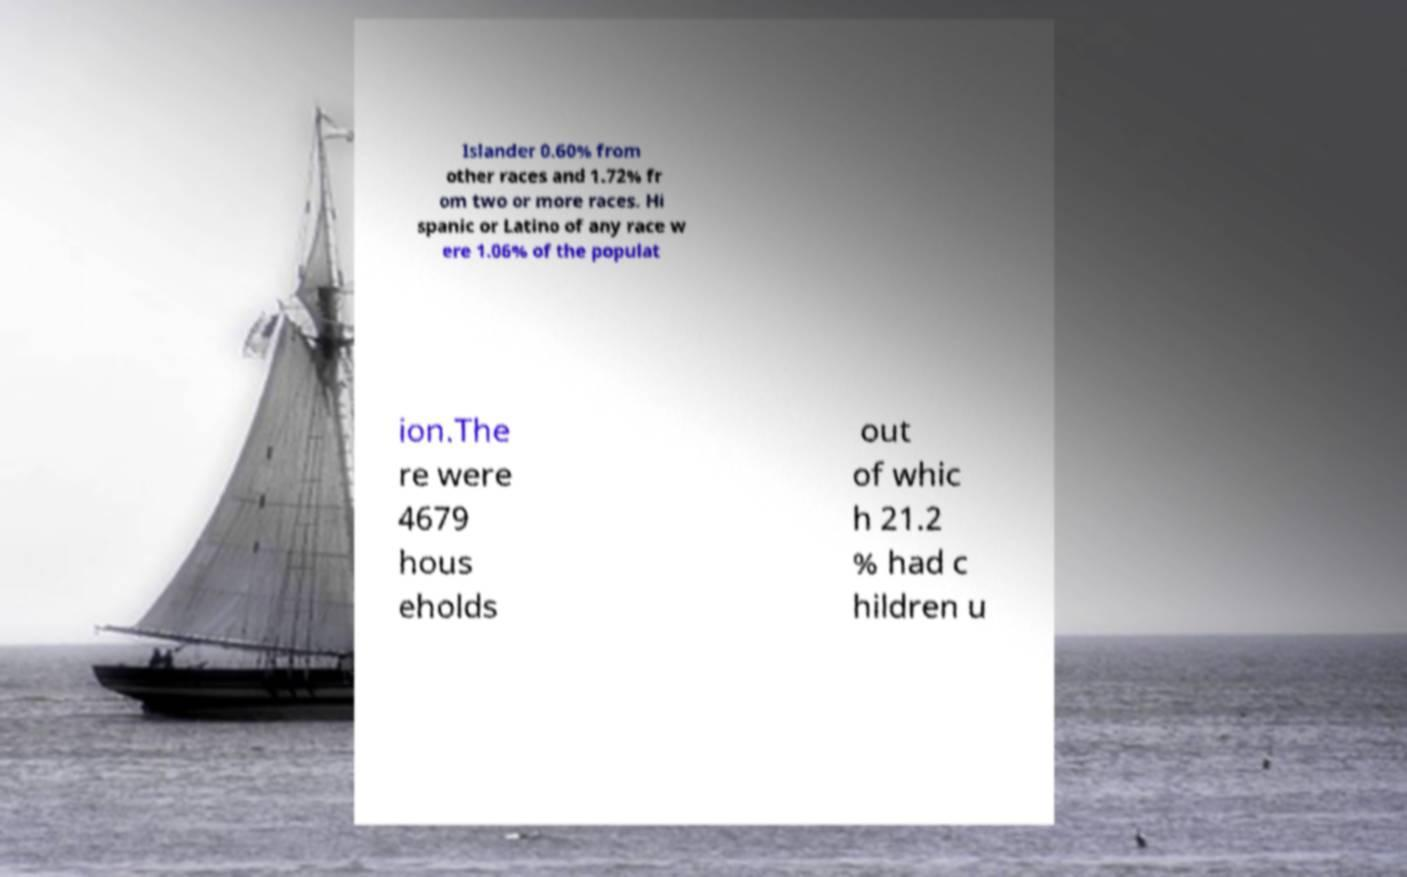For documentation purposes, I need the text within this image transcribed. Could you provide that? Islander 0.60% from other races and 1.72% fr om two or more races. Hi spanic or Latino of any race w ere 1.06% of the populat ion.The re were 4679 hous eholds out of whic h 21.2 % had c hildren u 